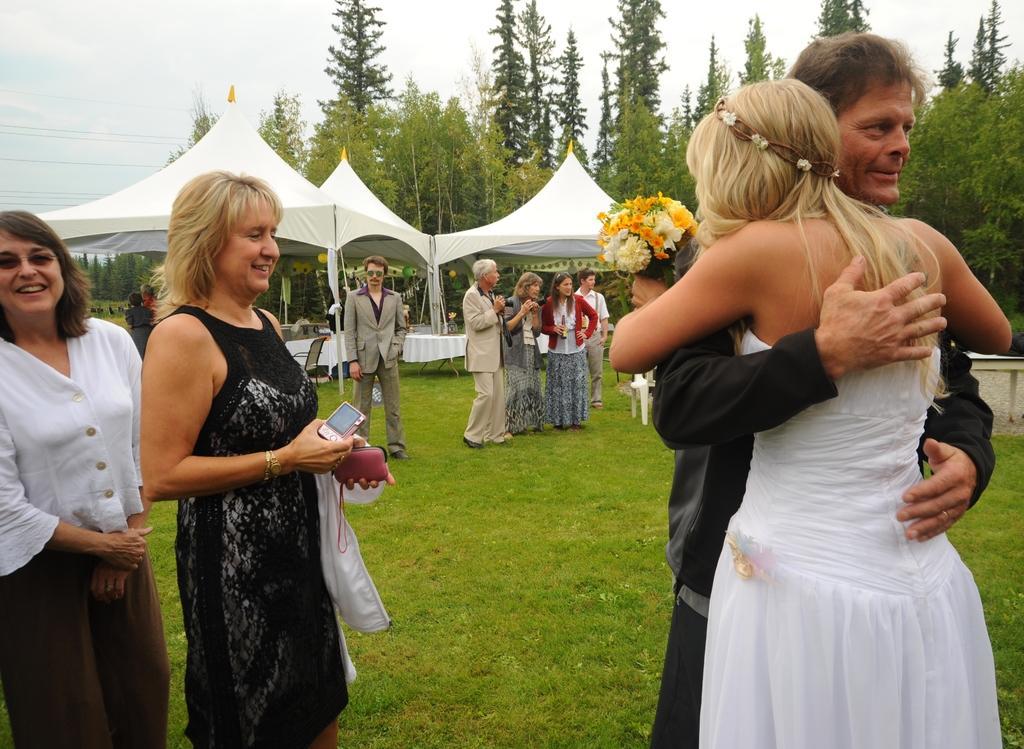Can you describe this image briefly? In this picture we can see some people standing on the grass, flower bouquet, camera, chairs, tents, tables, trees and some objects and in the background we can see the sky. 